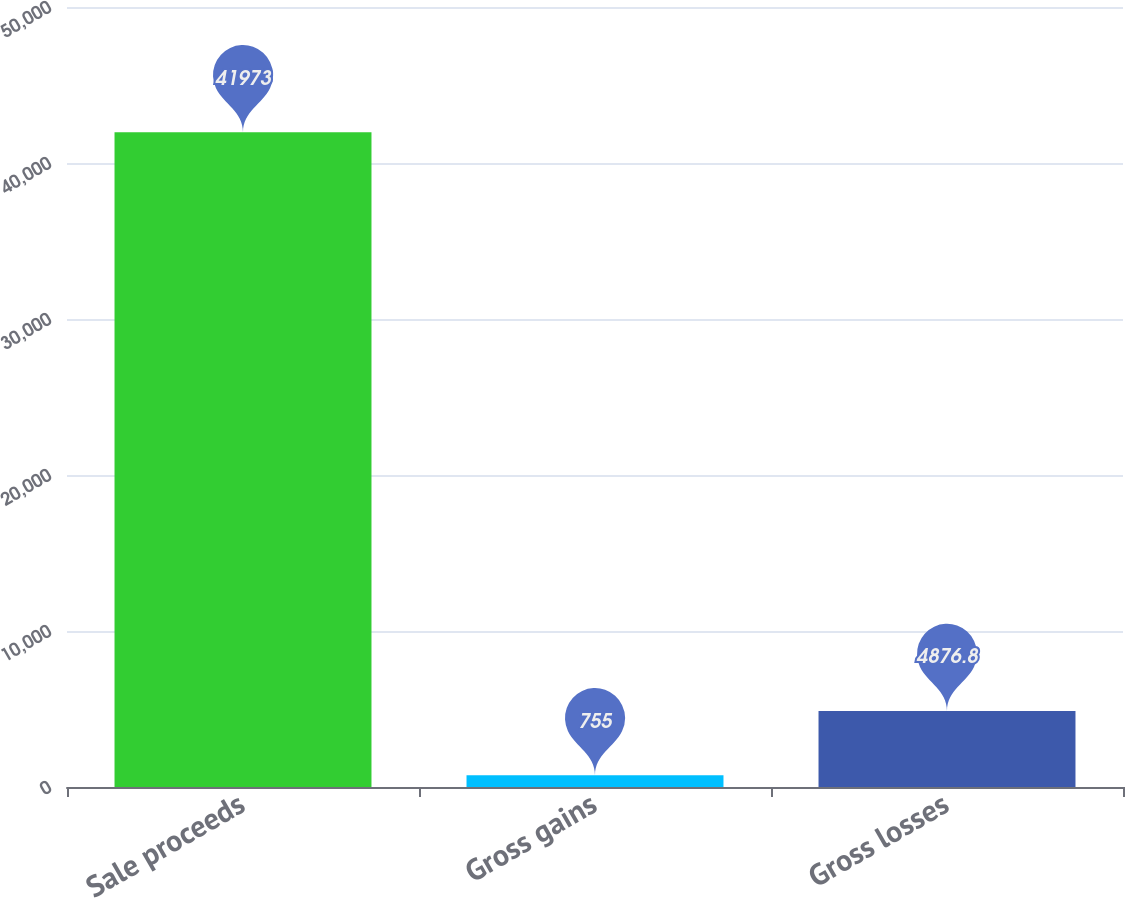Convert chart to OTSL. <chart><loc_0><loc_0><loc_500><loc_500><bar_chart><fcel>Sale proceeds<fcel>Gross gains<fcel>Gross losses<nl><fcel>41973<fcel>755<fcel>4876.8<nl></chart> 